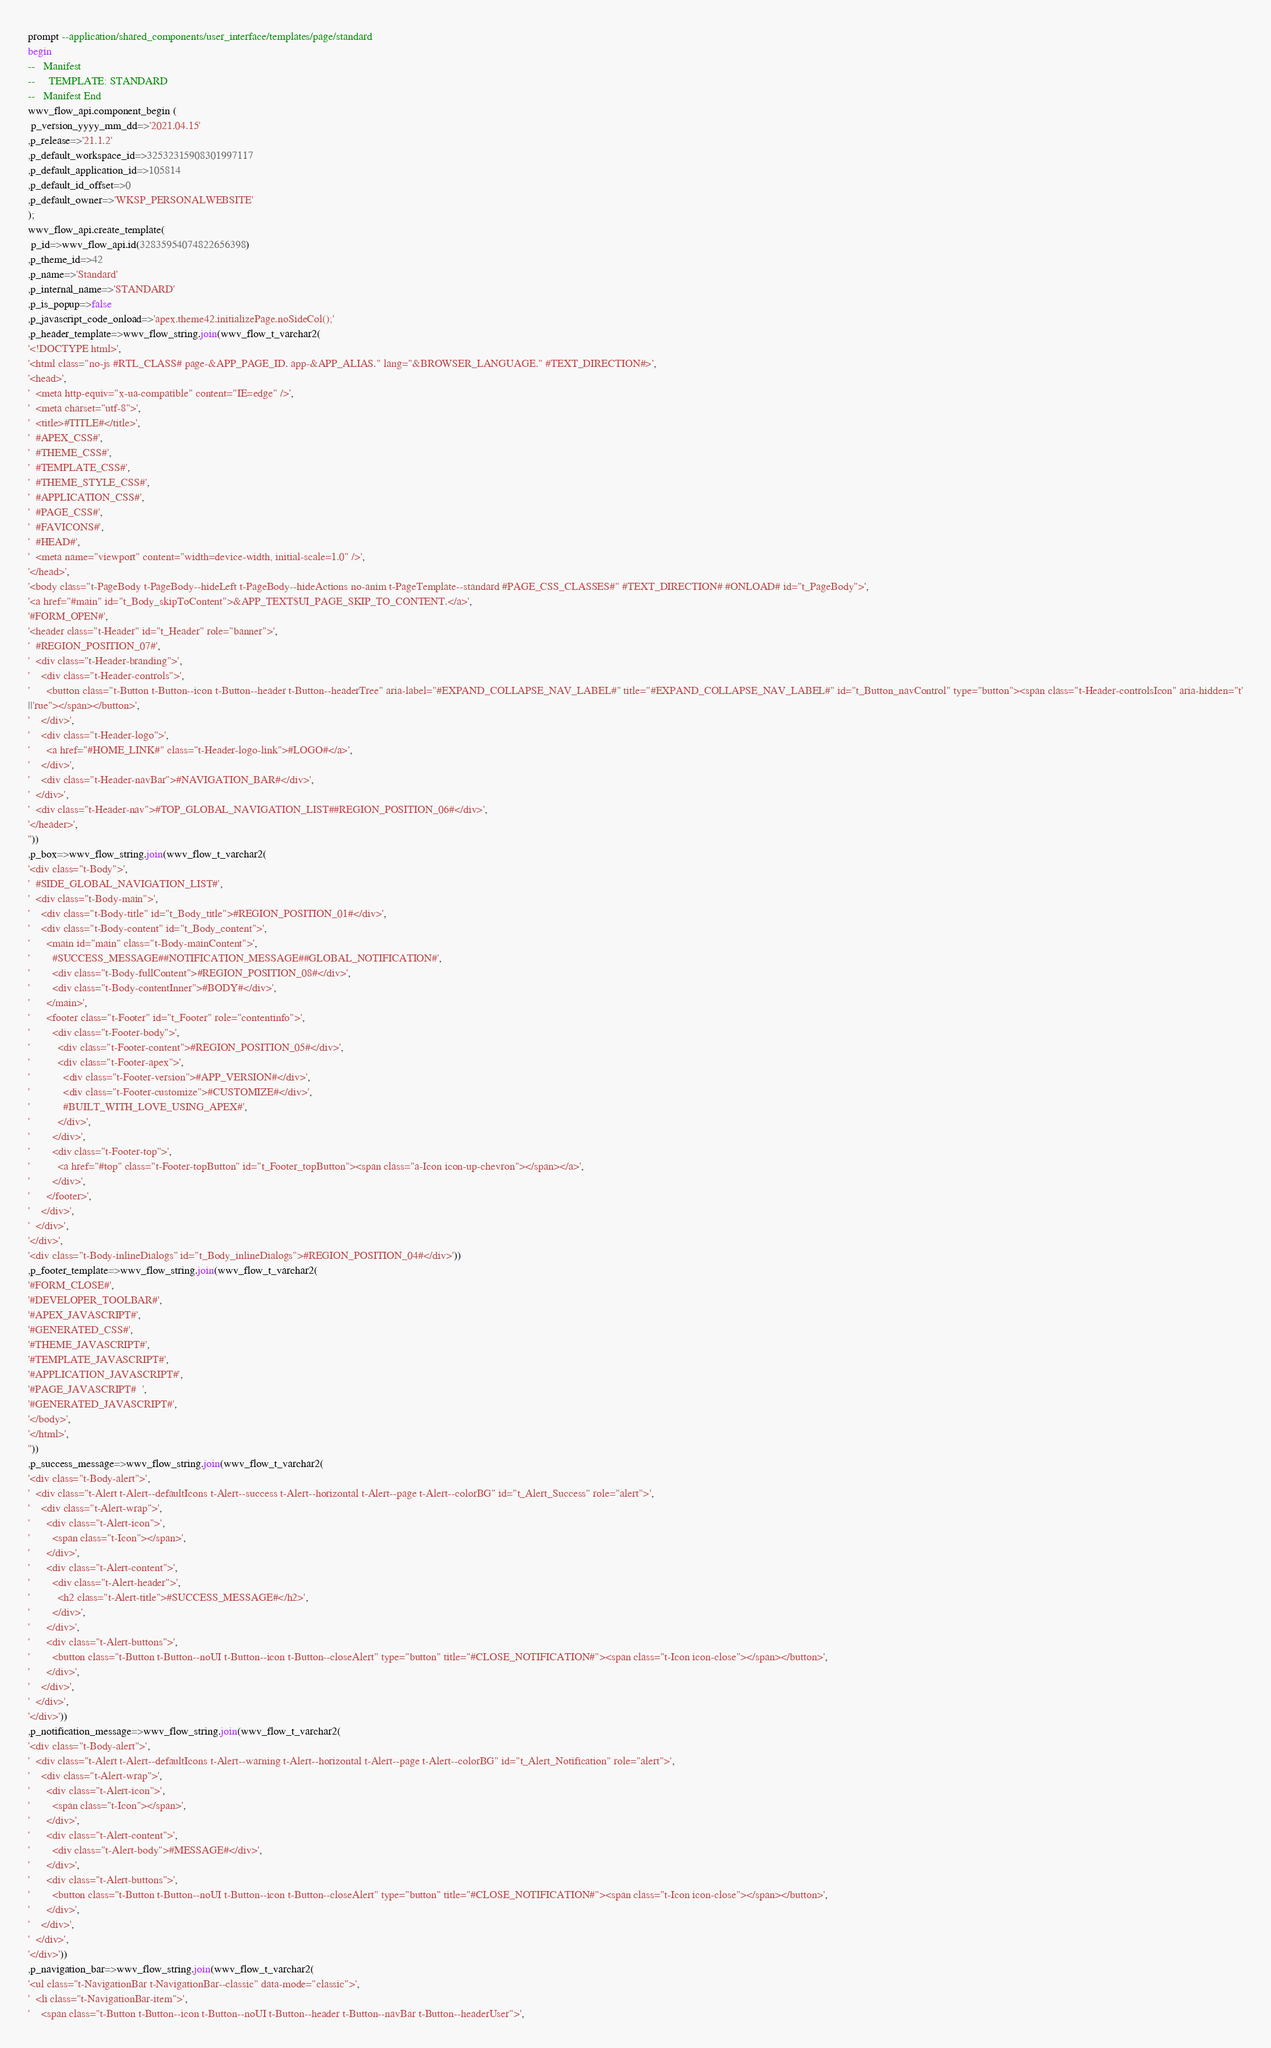Convert code to text. <code><loc_0><loc_0><loc_500><loc_500><_SQL_>prompt --application/shared_components/user_interface/templates/page/standard
begin
--   Manifest
--     TEMPLATE: STANDARD
--   Manifest End
wwv_flow_api.component_begin (
 p_version_yyyy_mm_dd=>'2021.04.15'
,p_release=>'21.1.2'
,p_default_workspace_id=>32532315908301997117
,p_default_application_id=>105814
,p_default_id_offset=>0
,p_default_owner=>'WKSP_PERSONALWEBSITE'
);
wwv_flow_api.create_template(
 p_id=>wwv_flow_api.id(32835954074822656398)
,p_theme_id=>42
,p_name=>'Standard'
,p_internal_name=>'STANDARD'
,p_is_popup=>false
,p_javascript_code_onload=>'apex.theme42.initializePage.noSideCol();'
,p_header_template=>wwv_flow_string.join(wwv_flow_t_varchar2(
'<!DOCTYPE html>',
'<html class="no-js #RTL_CLASS# page-&APP_PAGE_ID. app-&APP_ALIAS." lang="&BROWSER_LANGUAGE." #TEXT_DIRECTION#>',
'<head>',
'  <meta http-equiv="x-ua-compatible" content="IE=edge" />',
'  <meta charset="utf-8">',
'  <title>#TITLE#</title>',
'  #APEX_CSS#',
'  #THEME_CSS#',
'  #TEMPLATE_CSS#',
'  #THEME_STYLE_CSS#',
'  #APPLICATION_CSS#',
'  #PAGE_CSS#',
'  #FAVICONS#',
'  #HEAD#',
'  <meta name="viewport" content="width=device-width, initial-scale=1.0" />',
'</head>',
'<body class="t-PageBody t-PageBody--hideLeft t-PageBody--hideActions no-anim t-PageTemplate--standard #PAGE_CSS_CLASSES#" #TEXT_DIRECTION# #ONLOAD# id="t_PageBody">',
'<a href="#main" id="t_Body_skipToContent">&APP_TEXT$UI_PAGE_SKIP_TO_CONTENT.</a>',
'#FORM_OPEN#',
'<header class="t-Header" id="t_Header" role="banner">',
'  #REGION_POSITION_07#',
'  <div class="t-Header-branding">',
'    <div class="t-Header-controls">',
'      <button class="t-Button t-Button--icon t-Button--header t-Button--headerTree" aria-label="#EXPAND_COLLAPSE_NAV_LABEL#" title="#EXPAND_COLLAPSE_NAV_LABEL#" id="t_Button_navControl" type="button"><span class="t-Header-controlsIcon" aria-hidden="t'
||'rue"></span></button>',
'    </div>',
'    <div class="t-Header-logo">',
'      <a href="#HOME_LINK#" class="t-Header-logo-link">#LOGO#</a>',
'    </div>',
'    <div class="t-Header-navBar">#NAVIGATION_BAR#</div>',
'  </div>',
'  <div class="t-Header-nav">#TOP_GLOBAL_NAVIGATION_LIST##REGION_POSITION_06#</div>',
'</header>',
''))
,p_box=>wwv_flow_string.join(wwv_flow_t_varchar2(
'<div class="t-Body">',
'  #SIDE_GLOBAL_NAVIGATION_LIST#',
'  <div class="t-Body-main">',
'    <div class="t-Body-title" id="t_Body_title">#REGION_POSITION_01#</div>',
'    <div class="t-Body-content" id="t_Body_content">',
'      <main id="main" class="t-Body-mainContent">',
'        #SUCCESS_MESSAGE##NOTIFICATION_MESSAGE##GLOBAL_NOTIFICATION#',
'        <div class="t-Body-fullContent">#REGION_POSITION_08#</div>',
'        <div class="t-Body-contentInner">#BODY#</div>',
'      </main>',
'      <footer class="t-Footer" id="t_Footer" role="contentinfo">',
'        <div class="t-Footer-body">',
'          <div class="t-Footer-content">#REGION_POSITION_05#</div>',
'          <div class="t-Footer-apex">',
'            <div class="t-Footer-version">#APP_VERSION#</div>',
'            <div class="t-Footer-customize">#CUSTOMIZE#</div>',
'            #BUILT_WITH_LOVE_USING_APEX#',
'          </div>',
'        </div>',
'        <div class="t-Footer-top">',
'          <a href="#top" class="t-Footer-topButton" id="t_Footer_topButton"><span class="a-Icon icon-up-chevron"></span></a>',
'        </div>',
'      </footer>',
'    </div>',
'  </div>',
'</div>',
'<div class="t-Body-inlineDialogs" id="t_Body_inlineDialogs">#REGION_POSITION_04#</div>'))
,p_footer_template=>wwv_flow_string.join(wwv_flow_t_varchar2(
'#FORM_CLOSE#',
'#DEVELOPER_TOOLBAR#',
'#APEX_JAVASCRIPT#',
'#GENERATED_CSS#',
'#THEME_JAVASCRIPT#',
'#TEMPLATE_JAVASCRIPT#',
'#APPLICATION_JAVASCRIPT#',
'#PAGE_JAVASCRIPT#  ',
'#GENERATED_JAVASCRIPT#',
'</body>',
'</html>',
''))
,p_success_message=>wwv_flow_string.join(wwv_flow_t_varchar2(
'<div class="t-Body-alert">',
'  <div class="t-Alert t-Alert--defaultIcons t-Alert--success t-Alert--horizontal t-Alert--page t-Alert--colorBG" id="t_Alert_Success" role="alert">',
'    <div class="t-Alert-wrap">',
'      <div class="t-Alert-icon">',
'        <span class="t-Icon"></span>',
'      </div>',
'      <div class="t-Alert-content">',
'        <div class="t-Alert-header">',
'          <h2 class="t-Alert-title">#SUCCESS_MESSAGE#</h2>',
'        </div>',
'      </div>',
'      <div class="t-Alert-buttons">',
'        <button class="t-Button t-Button--noUI t-Button--icon t-Button--closeAlert" type="button" title="#CLOSE_NOTIFICATION#"><span class="t-Icon icon-close"></span></button>',
'      </div>',
'    </div>',
'  </div>',
'</div>'))
,p_notification_message=>wwv_flow_string.join(wwv_flow_t_varchar2(
'<div class="t-Body-alert">',
'  <div class="t-Alert t-Alert--defaultIcons t-Alert--warning t-Alert--horizontal t-Alert--page t-Alert--colorBG" id="t_Alert_Notification" role="alert">',
'    <div class="t-Alert-wrap">',
'      <div class="t-Alert-icon">',
'        <span class="t-Icon"></span>',
'      </div>',
'      <div class="t-Alert-content">',
'        <div class="t-Alert-body">#MESSAGE#</div>',
'      </div>',
'      <div class="t-Alert-buttons">',
'        <button class="t-Button t-Button--noUI t-Button--icon t-Button--closeAlert" type="button" title="#CLOSE_NOTIFICATION#"><span class="t-Icon icon-close"></span></button>',
'      </div>',
'    </div>',
'  </div>',
'</div>'))
,p_navigation_bar=>wwv_flow_string.join(wwv_flow_t_varchar2(
'<ul class="t-NavigationBar t-NavigationBar--classic" data-mode="classic">',
'  <li class="t-NavigationBar-item">',
'    <span class="t-Button t-Button--icon t-Button--noUI t-Button--header t-Button--navBar t-Button--headerUser">',</code> 